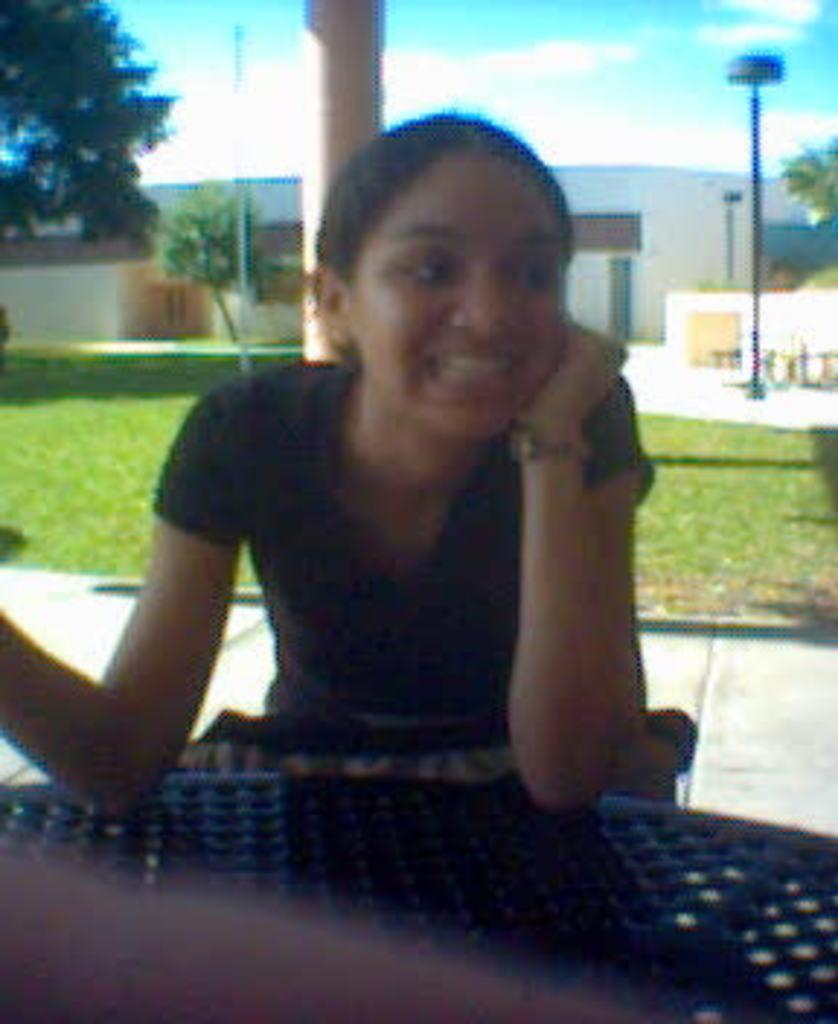What is the woman in the image doing? The woman is sitting in the image. What can be observed about the woman's attire? The woman is wearing clothes and a wrist watch. What is the woman's facial expression? The woman is smiling. What structures are visible behind the woman? There is a building, trees, a pole, a pillar, and grass behind the woman. What is the color of the sky in the image? The sky is pale blue. How many planes can be seen flying in the image? There are no planes visible in the image. What type of brush is the woman using to paint the grass in the image? There is no brush present in the image, and the woman is not depicted as painting the grass. 